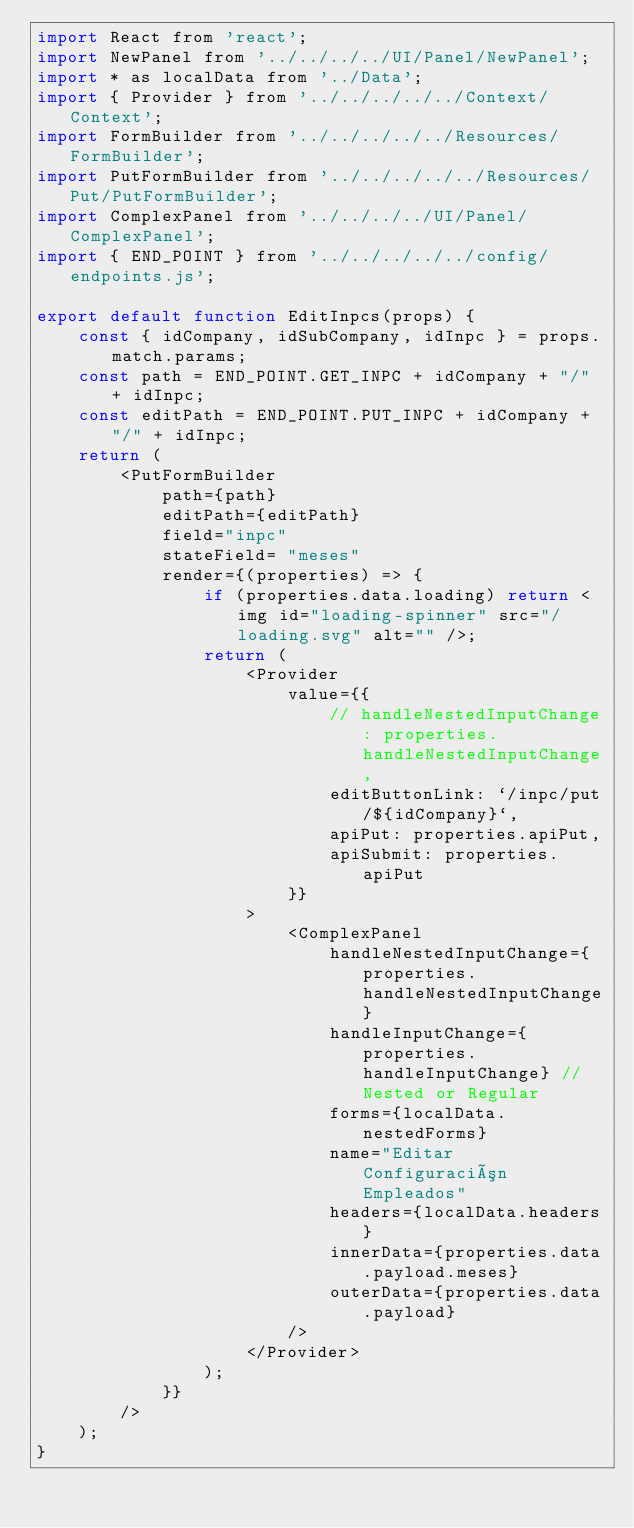Convert code to text. <code><loc_0><loc_0><loc_500><loc_500><_JavaScript_>import React from 'react';
import NewPanel from '../../../../UI/Panel/NewPanel';
import * as localData from '../Data';
import { Provider } from '../../../../../Context/Context';
import FormBuilder from '../../../../../Resources/FormBuilder';
import PutFormBuilder from '../../../../../Resources/Put/PutFormBuilder';
import ComplexPanel from '../../../../UI/Panel/ComplexPanel';
import { END_POINT } from '../../../../../config/endpoints.js';

export default function EditInpcs(props) {
	const { idCompany, idSubCompany, idInpc } = props.match.params;
	const path = END_POINT.GET_INPC + idCompany + "/" + idInpc;
	const editPath = END_POINT.PUT_INPC + idCompany + "/" + idInpc;
	return (
		<PutFormBuilder
			path={path}
			editPath={editPath}
			field="inpc"
			stateField= "meses"
			render={(properties) => {
				if (properties.data.loading) return <img id="loading-spinner" src="/loading.svg" alt="" />;
				return (
					<Provider
						value={{
							// handleNestedInputChange: properties.handleNestedInputChange,
							editButtonLink: `/inpc/put/${idCompany}`,
							apiPut: properties.apiPut,
							apiSubmit: properties.apiPut
						}}
					>
						<ComplexPanel
							handleNestedInputChange={properties.handleNestedInputChange}
							handleInputChange={properties.handleInputChange} // Nested or Regular
							forms={localData.nestedForms}
							name="Editar Configuración Empleados"
							headers={localData.headers}
							innerData={properties.data.payload.meses}
							outerData={properties.data.payload}
						/>
					</Provider>
				);
			}}
		/>
	);
}
</code> 